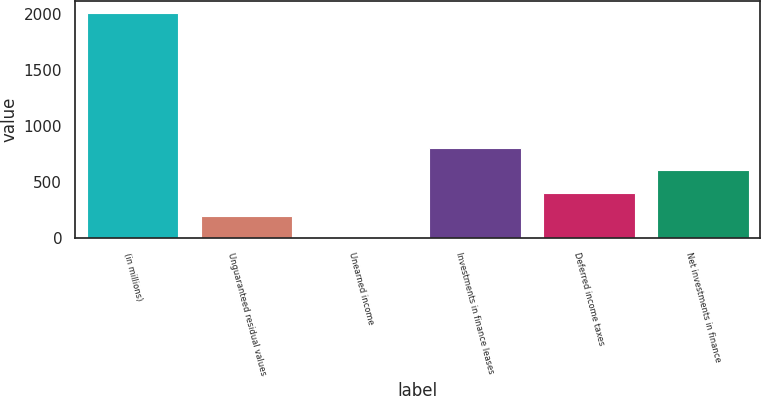Convert chart to OTSL. <chart><loc_0><loc_0><loc_500><loc_500><bar_chart><fcel>(in millions)<fcel>Unguaranteed residual values<fcel>Unearned income<fcel>Investments in finance leases<fcel>Deferred income taxes<fcel>Net investments in finance<nl><fcel>2011<fcel>202.9<fcel>2<fcel>805.6<fcel>403.8<fcel>604.7<nl></chart> 